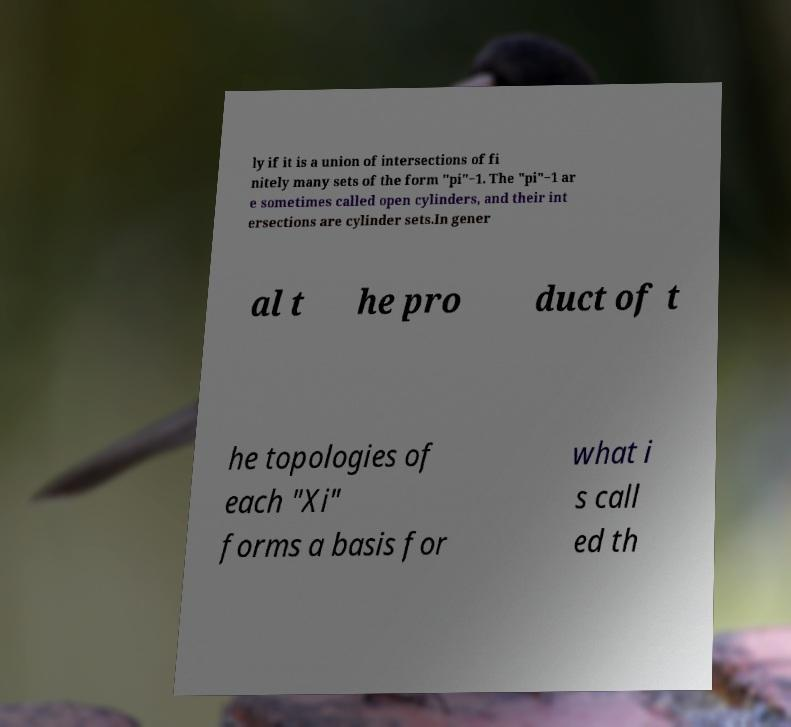For documentation purposes, I need the text within this image transcribed. Could you provide that? ly if it is a union of intersections of fi nitely many sets of the form "pi"−1. The "pi"−1 ar e sometimes called open cylinders, and their int ersections are cylinder sets.In gener al t he pro duct of t he topologies of each "Xi" forms a basis for what i s call ed th 